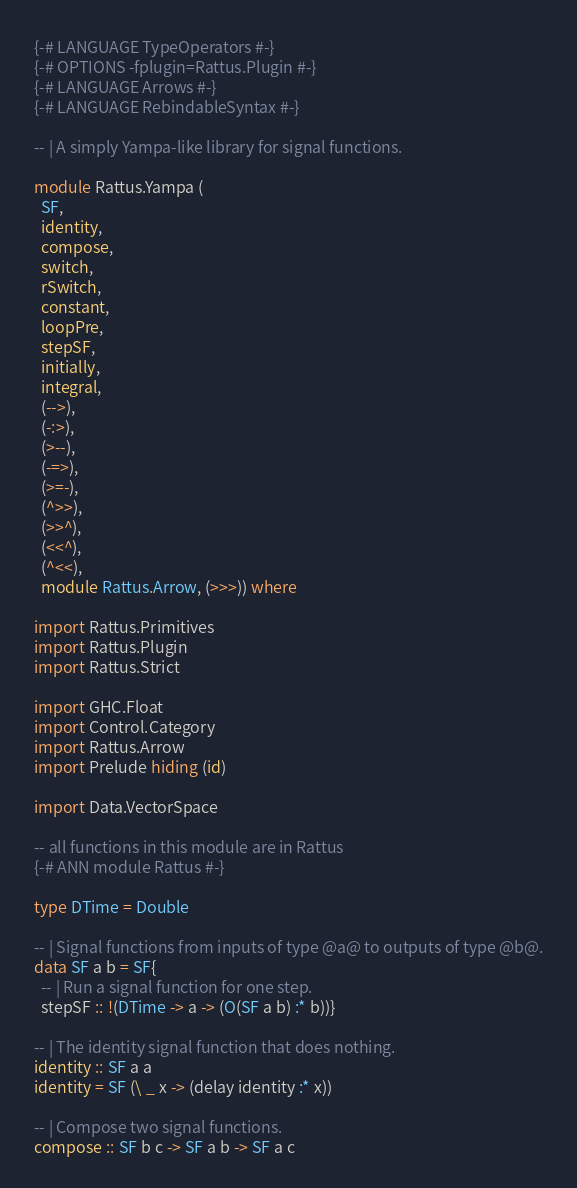Convert code to text. <code><loc_0><loc_0><loc_500><loc_500><_Haskell_>{-# LANGUAGE TypeOperators #-}
{-# OPTIONS -fplugin=Rattus.Plugin #-}
{-# LANGUAGE Arrows #-}
{-# LANGUAGE RebindableSyntax #-}

-- | A simply Yampa-like library for signal functions.

module Rattus.Yampa (
  SF,
  identity,
  compose,
  switch,
  rSwitch,
  constant,
  loopPre,
  stepSF,
  initially,
  integral,
  (-->),
  (-:>),
  (>--),
  (-=>),
  (>=-),
  (^>>),
  (>>^),
  (<<^),
  (^<<),
  module Rattus.Arrow, (>>>)) where

import Rattus.Primitives
import Rattus.Plugin
import Rattus.Strict

import GHC.Float
import Control.Category
import Rattus.Arrow
import Prelude hiding (id)

import Data.VectorSpace

-- all functions in this module are in Rattus 
{-# ANN module Rattus #-}

type DTime = Double 

-- | Signal functions from inputs of type @a@ to outputs of type @b@.
data SF a b = SF{
  -- | Run a signal function for one step.
  stepSF :: !(DTime -> a -> (O(SF a b) :* b))}

-- | The identity signal function that does nothing.
identity :: SF a a
identity = SF (\ _ x -> (delay identity :* x))

-- | Compose two signal functions.
compose :: SF b c -> SF a b -> SF a c</code> 